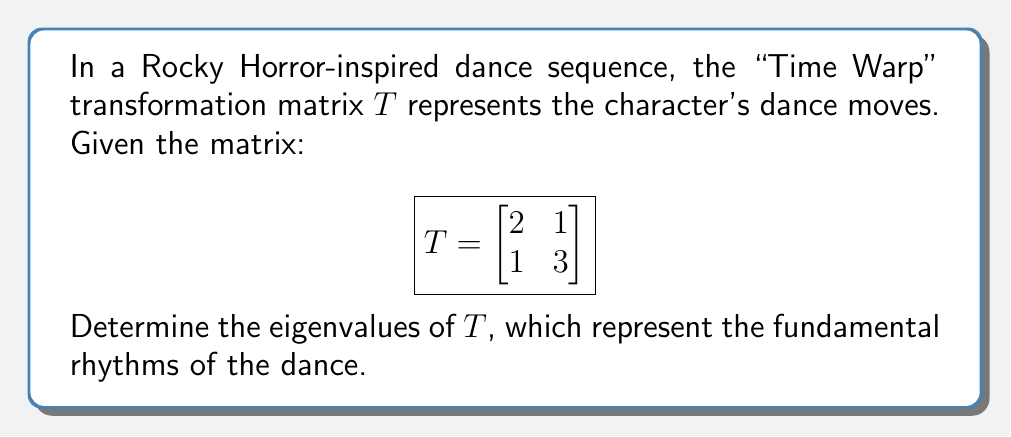Provide a solution to this math problem. To find the eigenvalues of the transformation matrix $T$, we follow these steps:

1) The characteristic equation for eigenvalues $\lambda$ is given by:
   $\det(T - \lambda I) = 0$, where $I$ is the 2x2 identity matrix.

2) Expand the determinant:
   $$\det\begin{bmatrix}
   2-\lambda & 1 \\
   1 & 3-\lambda
   \end{bmatrix} = 0$$

3) Calculate the determinant:
   $(2-\lambda)(3-\lambda) - 1 \cdot 1 = 0$

4) Expand the equation:
   $6 - 5\lambda + \lambda^2 - 1 = 0$
   $\lambda^2 - 5\lambda + 5 = 0$

5) This is a quadratic equation. We can solve it using the quadratic formula:
   $\lambda = \frac{-b \pm \sqrt{b^2 - 4ac}}{2a}$

   Where $a=1$, $b=-5$, and $c=5$

6) Substituting these values:
   $\lambda = \frac{5 \pm \sqrt{25 - 20}}{2} = \frac{5 \pm \sqrt{5}}{2}$

7) Therefore, the two eigenvalues are:
   $\lambda_1 = \frac{5 + \sqrt{5}}{2}$ and $\lambda_2 = \frac{5 - \sqrt{5}}{2}$
Answer: $\lambda_1 = \frac{5 + \sqrt{5}}{2}$, $\lambda_2 = \frac{5 - \sqrt{5}}{2}$ 